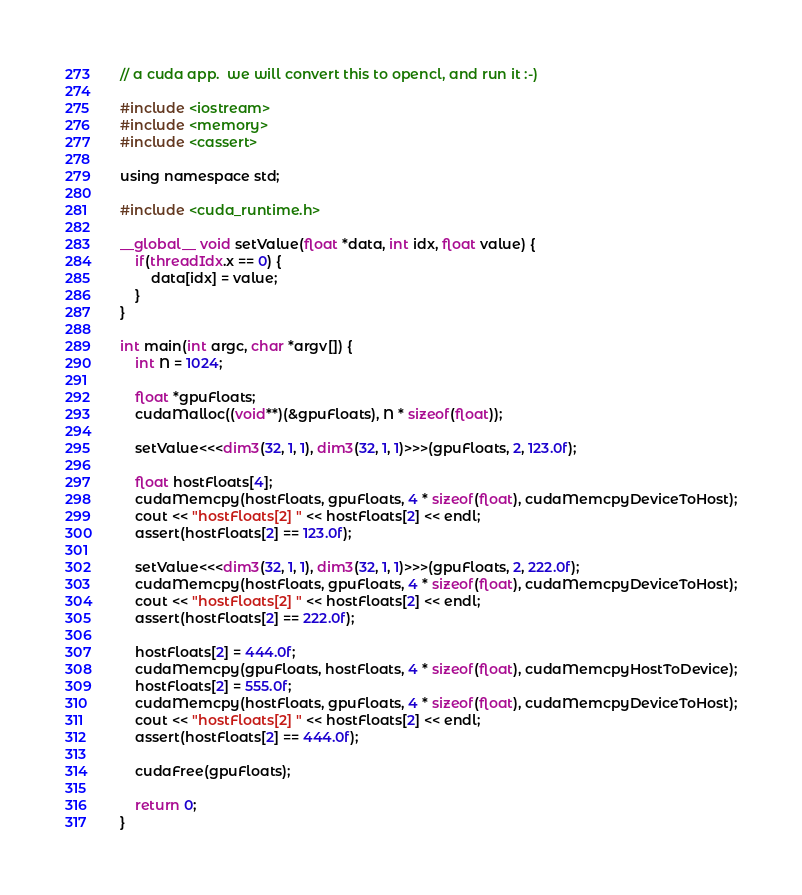<code> <loc_0><loc_0><loc_500><loc_500><_Cuda_>// a cuda app.  we will convert this to opencl, and run it :-)

#include <iostream>
#include <memory>
#include <cassert>

using namespace std;

#include <cuda_runtime.h>

__global__ void setValue(float *data, int idx, float value) {
    if(threadIdx.x == 0) {
        data[idx] = value;
    }
}

int main(int argc, char *argv[]) {
    int N = 1024;

    float *gpuFloats;
    cudaMalloc((void**)(&gpuFloats), N * sizeof(float));

    setValue<<<dim3(32, 1, 1), dim3(32, 1, 1)>>>(gpuFloats, 2, 123.0f);

    float hostFloats[4];
    cudaMemcpy(hostFloats, gpuFloats, 4 * sizeof(float), cudaMemcpyDeviceToHost);
    cout << "hostFloats[2] " << hostFloats[2] << endl;
    assert(hostFloats[2] == 123.0f);

    setValue<<<dim3(32, 1, 1), dim3(32, 1, 1)>>>(gpuFloats, 2, 222.0f);
    cudaMemcpy(hostFloats, gpuFloats, 4 * sizeof(float), cudaMemcpyDeviceToHost);
    cout << "hostFloats[2] " << hostFloats[2] << endl;
    assert(hostFloats[2] == 222.0f);

    hostFloats[2] = 444.0f;
    cudaMemcpy(gpuFloats, hostFloats, 4 * sizeof(float), cudaMemcpyHostToDevice);
    hostFloats[2] = 555.0f;
    cudaMemcpy(hostFloats, gpuFloats, 4 * sizeof(float), cudaMemcpyDeviceToHost);
    cout << "hostFloats[2] " << hostFloats[2] << endl;
    assert(hostFloats[2] == 444.0f);

    cudaFree(gpuFloats);

    return 0;
}
</code> 